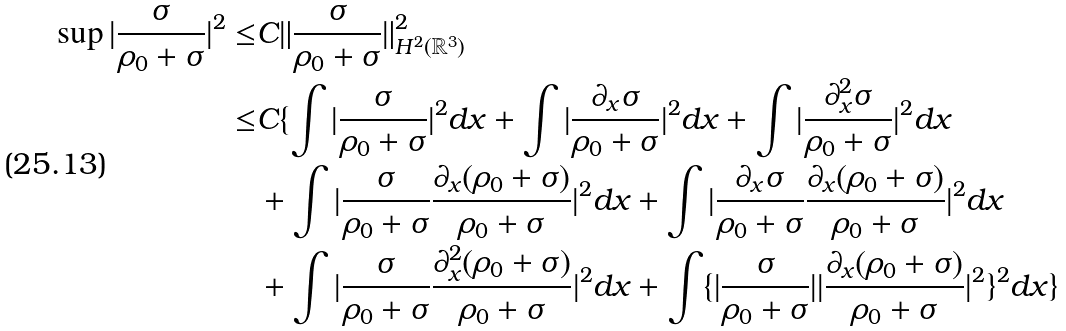Convert formula to latex. <formula><loc_0><loc_0><loc_500><loc_500>\sup | \frac { \sigma } { \rho _ { 0 } + \sigma } | ^ { 2 } \leq & C \| \frac { \sigma } { \rho _ { 0 } + \sigma } \| _ { H ^ { 2 } ( { \mathbb { R } ^ { 3 } } ) } ^ { 2 } \\ \leq & C \{ \int | \frac { \sigma } { \rho _ { 0 } + \sigma } | ^ { 2 } d x + \int | \frac { \partial _ { x } \sigma } { \rho _ { 0 } + \sigma } | ^ { 2 } d x + \int | \frac { \partial _ { x } ^ { 2 } \sigma } { \rho _ { 0 } + \sigma } | ^ { 2 } d x \\ & + \int | \frac { \sigma } { \rho _ { 0 } + \sigma } \frac { \partial _ { x } ( \rho _ { 0 } + \sigma ) } { \rho _ { 0 } + \sigma } | ^ { 2 } d x + \int | \frac { \partial _ { x } \sigma } { \rho _ { 0 } + \sigma } \frac { \partial _ { x } ( \rho _ { 0 } + \sigma ) } { \rho _ { 0 } + \sigma } | ^ { 2 } d x \\ & + \int | \frac { \sigma } { \rho _ { 0 } + \sigma } \frac { \partial _ { x } ^ { 2 } ( \rho _ { 0 } + \sigma ) } { \rho _ { 0 } + \sigma } | ^ { 2 } d x + \int \{ | \frac { \sigma } { \rho _ { 0 } + \sigma } | | \frac { \partial _ { x } ( \rho _ { 0 } + \sigma ) } { \rho _ { 0 } + \sigma } | ^ { 2 } \} ^ { 2 } d x \}</formula> 